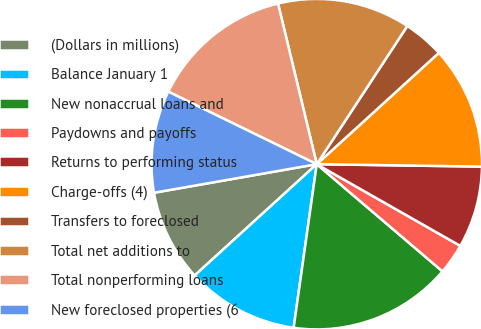Convert chart. <chart><loc_0><loc_0><loc_500><loc_500><pie_chart><fcel>(Dollars in millions)<fcel>Balance January 1<fcel>New nonaccrual loans and<fcel>Paydowns and payoffs<fcel>Returns to performing status<fcel>Charge-offs (4)<fcel>Transfers to foreclosed<fcel>Total net additions to<fcel>Total nonperforming loans<fcel>New foreclosed properties (6<nl><fcel>9.0%<fcel>11.0%<fcel>16.0%<fcel>3.0%<fcel>8.0%<fcel>12.0%<fcel>4.0%<fcel>13.0%<fcel>14.0%<fcel>10.0%<nl></chart> 